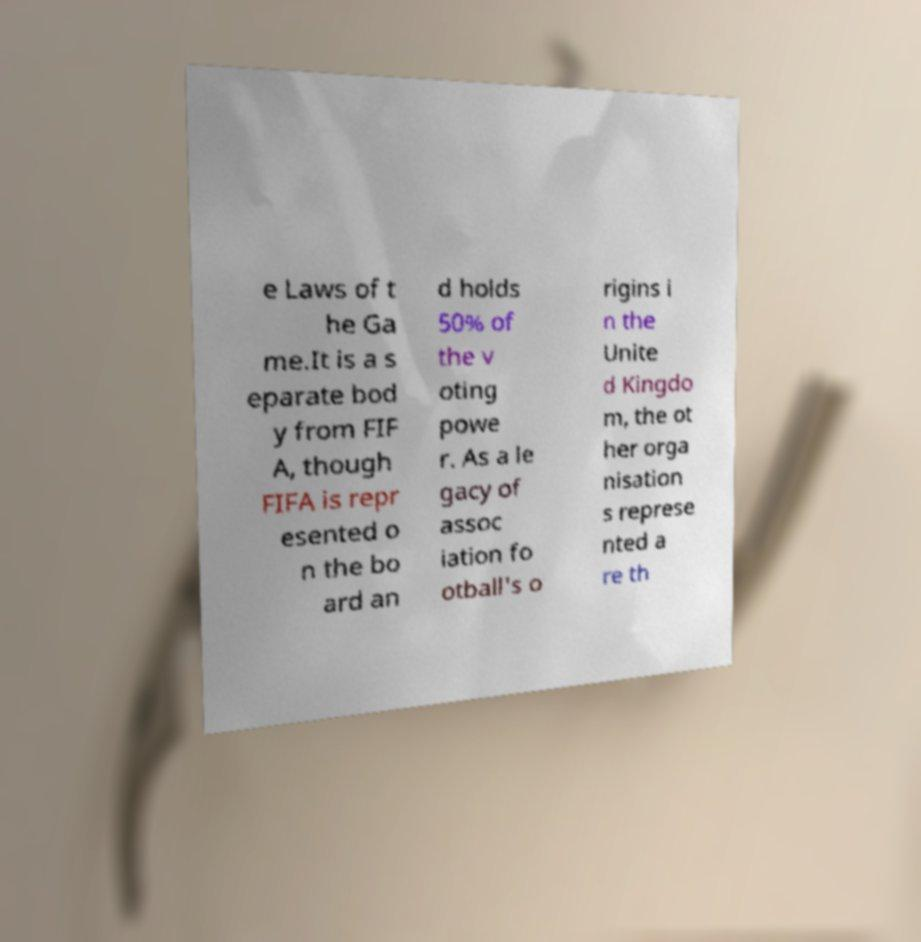Please read and relay the text visible in this image. What does it say? e Laws of t he Ga me.It is a s eparate bod y from FIF A, though FIFA is repr esented o n the bo ard an d holds 50% of the v oting powe r. As a le gacy of assoc iation fo otball's o rigins i n the Unite d Kingdo m, the ot her orga nisation s represe nted a re th 